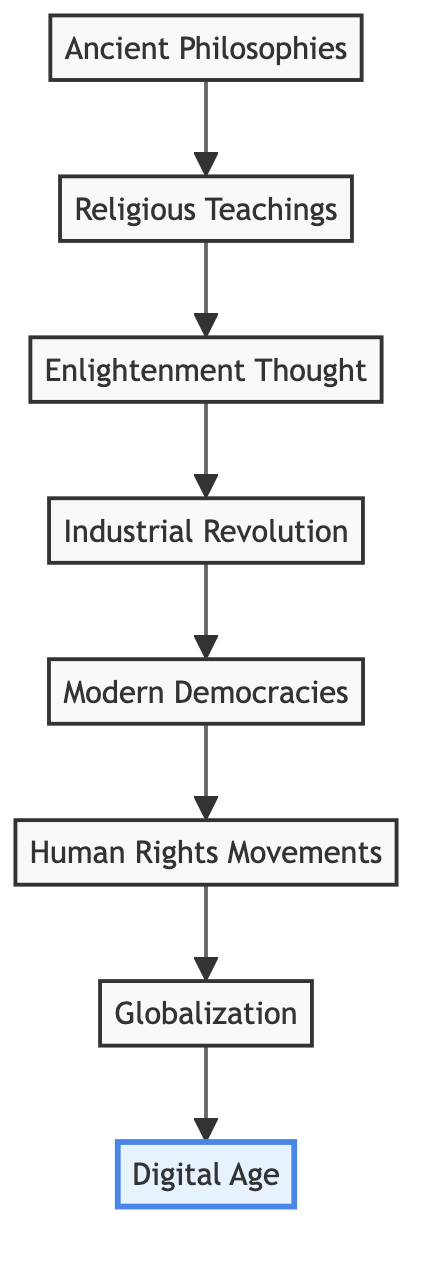What is the first element in the flow chart? The first element in the flow chart is "Ancient Philosophies," which is positioned at the bottom of the diagram.
Answer: Ancient Philosophies How many elements are present in the flow chart? There are a total of eight elements listed in the flow chart, each depicting a step in the evolution of modern societal values.
Answer: 8 What element follows the Enlightenment Thought? Following "Enlightenment Thought," the next element in the flow chart is "Industrial Revolution." This shows the direct progression from Enlightenment ideas to industrial changes.
Answer: Industrial Revolution Which element is highlighted in the diagram? The "Digital Age" element is highlighted in the diagram, which indicates its significance as the most contemporary topic in the flow of societal values.
Answer: Digital Age What is the connection between Religious Teachings and Enlightenment Thought? "Religious Teachings" leads to "Enlightenment Thought," indicating that religious beliefs helped shape the ideas of reason and individualism during the Enlightenment.
Answer: leads to How does the flow from Human Rights Movements to Globalization reflect societal changes? The flow from "Human Rights Movements" to "Globalization" suggests that the advocacy for rights has influenced and been influenced by global interconnectedness, reflecting changes in societal values towards shared global ethics.
Answer: Mutual influence What is the relationship between the Industrial Revolution and Modern Democracies? The Industrial Revolution leads to Modern Democracies, showing that the changes brought by industrialization contributed to the development and shaping of democratic values such as liberty and equality.
Answer: leads to What is the last element of the flow chart? The last element in the flow chart is "Digital Age," located at the top, which represents the culmination of the evolution of societal values in contemporary times.
Answer: Digital Age Which pair of elements indicates a transition from historical to modern values? The pair "Ancient Philosophies" and "Modern Democracies" indicates a clear transition from historical values rooted in ancient traditions to contemporary democratic ideals.
Answer: Ancient Philosophies, Modern Democracies 